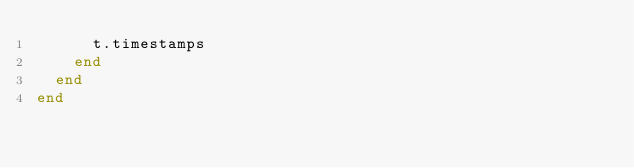<code> <loc_0><loc_0><loc_500><loc_500><_Ruby_>      t.timestamps
    end
  end
end
</code> 